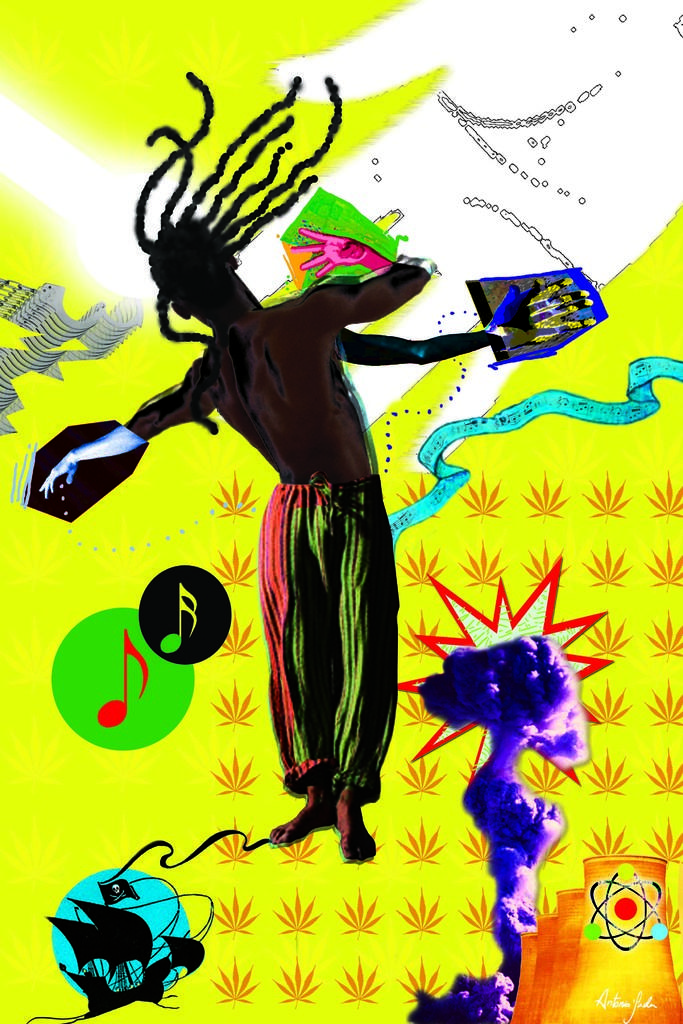What type of artwork is depicted in the image? The image is a painting. Can you describe the subject matter of the painting? There is a person in the painting. What other objects or elements are present in the painting? There are kites in the painting. What type of dinner is being served in the painting? There is no dinner present in the painting; it features a person and kites. Can you point out the cactus in the painting? There is no cactus present in the painting; it only features a person and kites. 